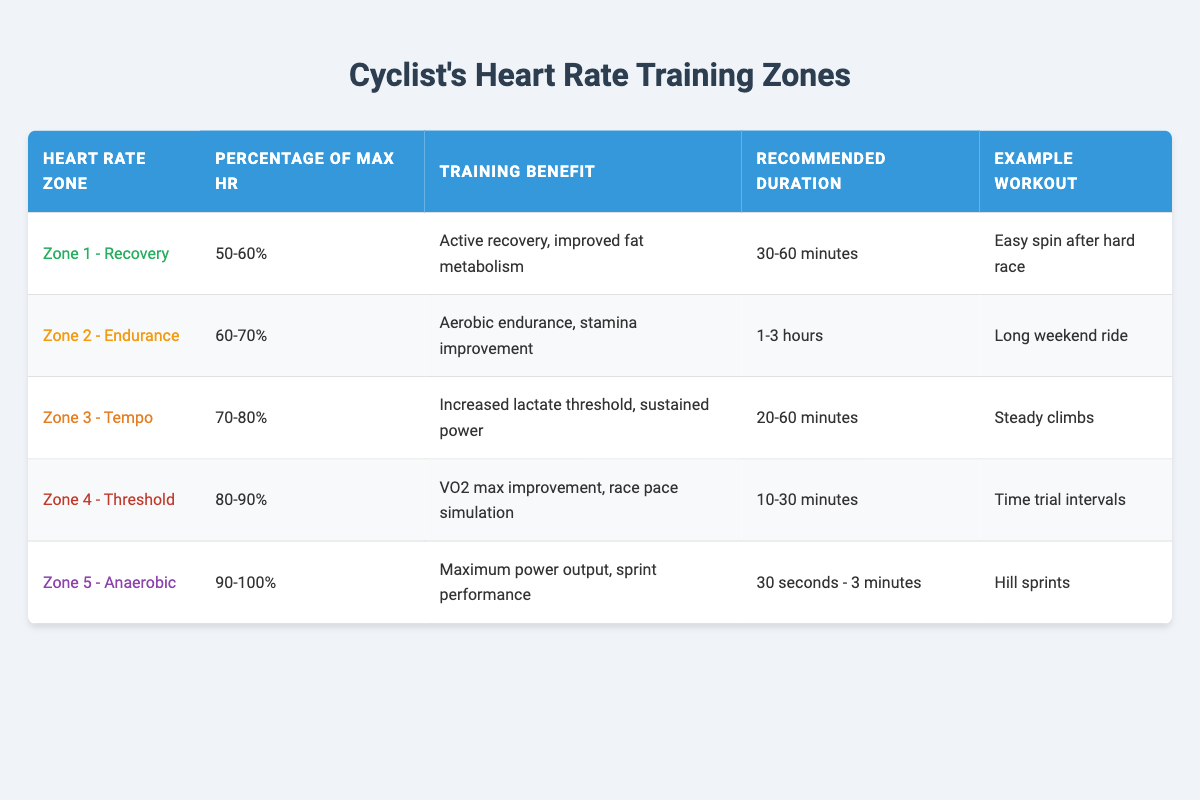What is the recommended duration for Zone 2 training? Zone 2 is defined as 60-70% of maximum heart rate and has a recommended duration of 1-3 hours for training. This information is directly available in the table under the "Recommended Duration" column for Zone 2.
Answer: 1-3 hours Which heart rate zone focuses on maximum power output? The heart rate zone focusing on maximum power output is Zone 5. This is specified in the "Heart Rate Zone" column, where Zone 5 is identified as "Anaerobic."
Answer: Zone 5 What is the training benefit of Zone 3? Zone 3's training benefit, as stated in the table, is increased lactate threshold and sustained power. This information can be found under the "Training Benefit" column for Zone 3.
Answer: Increased lactate threshold, sustained power Is the recommended duration for Zone 4 longer than for Zone 1? The recommended duration for Zone 4 is 10-30 minutes, whereas for Zone 1 it is 30-60 minutes. Since 30-60 minutes is longer than 10-30 minutes, the statement is true.
Answer: Yes What is the average recommended duration of training across all zones? The recommended durations for each zone are: Zone 1 (30-60 minutes), Zone 2 (1-3 hours = 60-180 minutes), Zone 3 (20-60 minutes), Zone 4 (10-30 minutes), Zone 5 (30 seconds - 3 minutes = 0.5 - 3 minutes). To calculate the average, we convert them to the same unit and then find the midpoint or reasonable value for clarity: (45 + 120 + 40 + 20 + 1.5) / 5 = 45.5 minutes on average. Therefore, averaging over these gives an approximate average training duration.
Answer: 45.5 minutes What percentage of maximum heart rate defines Zone 1? Zone 1 is defined as 50-60% of maximum heart rate, as indicated in the "Percentage of Max HR" column for Zone 1.
Answer: 50-60% 